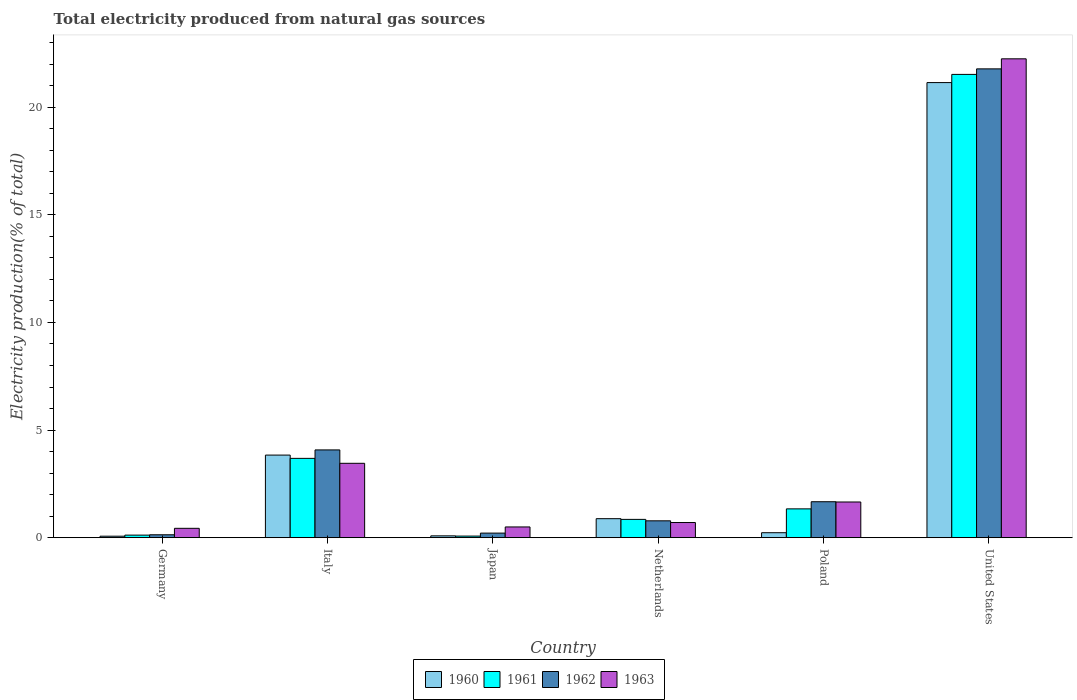How many groups of bars are there?
Provide a succinct answer. 6. Are the number of bars per tick equal to the number of legend labels?
Ensure brevity in your answer.  Yes. Are the number of bars on each tick of the X-axis equal?
Your answer should be compact. Yes. How many bars are there on the 5th tick from the right?
Your response must be concise. 4. What is the label of the 5th group of bars from the left?
Offer a terse response. Poland. In how many cases, is the number of bars for a given country not equal to the number of legend labels?
Provide a succinct answer. 0. What is the total electricity produced in 1960 in United States?
Offer a very short reply. 21.14. Across all countries, what is the maximum total electricity produced in 1962?
Give a very brief answer. 21.78. Across all countries, what is the minimum total electricity produced in 1960?
Offer a terse response. 0.07. In which country was the total electricity produced in 1963 minimum?
Your response must be concise. Germany. What is the total total electricity produced in 1961 in the graph?
Make the answer very short. 27.59. What is the difference between the total electricity produced in 1963 in Italy and that in Poland?
Offer a terse response. 1.8. What is the difference between the total electricity produced in 1961 in Poland and the total electricity produced in 1963 in Netherlands?
Your answer should be very brief. 0.63. What is the average total electricity produced in 1962 per country?
Ensure brevity in your answer.  4.78. What is the difference between the total electricity produced of/in 1960 and total electricity produced of/in 1961 in United States?
Your answer should be compact. -0.38. In how many countries, is the total electricity produced in 1962 greater than 7 %?
Offer a terse response. 1. What is the ratio of the total electricity produced in 1962 in Germany to that in Japan?
Keep it short and to the point. 0.64. What is the difference between the highest and the second highest total electricity produced in 1961?
Your answer should be compact. -2.35. What is the difference between the highest and the lowest total electricity produced in 1961?
Your response must be concise. 21.45. What does the 1st bar from the left in Italy represents?
Give a very brief answer. 1960. What does the 3rd bar from the right in Japan represents?
Your answer should be very brief. 1961. How many bars are there?
Make the answer very short. 24. Are all the bars in the graph horizontal?
Offer a terse response. No. How many countries are there in the graph?
Provide a succinct answer. 6. Are the values on the major ticks of Y-axis written in scientific E-notation?
Your answer should be compact. No. Does the graph contain any zero values?
Make the answer very short. No. Does the graph contain grids?
Your answer should be compact. No. How many legend labels are there?
Give a very brief answer. 4. What is the title of the graph?
Make the answer very short. Total electricity produced from natural gas sources. What is the label or title of the X-axis?
Your response must be concise. Country. What is the Electricity production(% of total) of 1960 in Germany?
Provide a succinct answer. 0.07. What is the Electricity production(% of total) of 1961 in Germany?
Provide a succinct answer. 0.12. What is the Electricity production(% of total) in 1962 in Germany?
Keep it short and to the point. 0.14. What is the Electricity production(% of total) of 1963 in Germany?
Your answer should be compact. 0.44. What is the Electricity production(% of total) of 1960 in Italy?
Provide a succinct answer. 3.84. What is the Electricity production(% of total) of 1961 in Italy?
Your answer should be compact. 3.69. What is the Electricity production(% of total) of 1962 in Italy?
Provide a short and direct response. 4.08. What is the Electricity production(% of total) in 1963 in Italy?
Ensure brevity in your answer.  3.46. What is the Electricity production(% of total) of 1960 in Japan?
Offer a very short reply. 0.09. What is the Electricity production(% of total) of 1961 in Japan?
Your response must be concise. 0.08. What is the Electricity production(% of total) of 1962 in Japan?
Ensure brevity in your answer.  0.21. What is the Electricity production(% of total) in 1963 in Japan?
Your response must be concise. 0.5. What is the Electricity production(% of total) of 1960 in Netherlands?
Make the answer very short. 0.88. What is the Electricity production(% of total) of 1961 in Netherlands?
Your response must be concise. 0.85. What is the Electricity production(% of total) of 1962 in Netherlands?
Your answer should be very brief. 0.78. What is the Electricity production(% of total) of 1963 in Netherlands?
Keep it short and to the point. 0.71. What is the Electricity production(% of total) of 1960 in Poland?
Make the answer very short. 0.23. What is the Electricity production(% of total) in 1961 in Poland?
Give a very brief answer. 1.34. What is the Electricity production(% of total) of 1962 in Poland?
Your answer should be very brief. 1.67. What is the Electricity production(% of total) of 1963 in Poland?
Provide a succinct answer. 1.66. What is the Electricity production(% of total) in 1960 in United States?
Your answer should be compact. 21.14. What is the Electricity production(% of total) in 1961 in United States?
Make the answer very short. 21.52. What is the Electricity production(% of total) in 1962 in United States?
Make the answer very short. 21.78. What is the Electricity production(% of total) in 1963 in United States?
Your answer should be very brief. 22.24. Across all countries, what is the maximum Electricity production(% of total) of 1960?
Make the answer very short. 21.14. Across all countries, what is the maximum Electricity production(% of total) of 1961?
Make the answer very short. 21.52. Across all countries, what is the maximum Electricity production(% of total) in 1962?
Your answer should be very brief. 21.78. Across all countries, what is the maximum Electricity production(% of total) in 1963?
Your response must be concise. 22.24. Across all countries, what is the minimum Electricity production(% of total) in 1960?
Your answer should be compact. 0.07. Across all countries, what is the minimum Electricity production(% of total) in 1961?
Provide a short and direct response. 0.08. Across all countries, what is the minimum Electricity production(% of total) of 1962?
Your answer should be compact. 0.14. Across all countries, what is the minimum Electricity production(% of total) in 1963?
Your response must be concise. 0.44. What is the total Electricity production(% of total) in 1960 in the graph?
Provide a short and direct response. 26.25. What is the total Electricity production(% of total) in 1961 in the graph?
Keep it short and to the point. 27.59. What is the total Electricity production(% of total) of 1962 in the graph?
Ensure brevity in your answer.  28.66. What is the total Electricity production(% of total) in 1963 in the graph?
Provide a succinct answer. 29. What is the difference between the Electricity production(% of total) of 1960 in Germany and that in Italy?
Provide a succinct answer. -3.77. What is the difference between the Electricity production(% of total) of 1961 in Germany and that in Italy?
Give a very brief answer. -3.57. What is the difference between the Electricity production(% of total) of 1962 in Germany and that in Italy?
Provide a short and direct response. -3.94. What is the difference between the Electricity production(% of total) of 1963 in Germany and that in Italy?
Your answer should be compact. -3.02. What is the difference between the Electricity production(% of total) in 1960 in Germany and that in Japan?
Your answer should be compact. -0.02. What is the difference between the Electricity production(% of total) of 1961 in Germany and that in Japan?
Offer a terse response. 0.04. What is the difference between the Electricity production(% of total) of 1962 in Germany and that in Japan?
Provide a short and direct response. -0.08. What is the difference between the Electricity production(% of total) in 1963 in Germany and that in Japan?
Your answer should be compact. -0.06. What is the difference between the Electricity production(% of total) of 1960 in Germany and that in Netherlands?
Provide a short and direct response. -0.81. What is the difference between the Electricity production(% of total) in 1961 in Germany and that in Netherlands?
Offer a terse response. -0.73. What is the difference between the Electricity production(% of total) in 1962 in Germany and that in Netherlands?
Keep it short and to the point. -0.65. What is the difference between the Electricity production(% of total) in 1963 in Germany and that in Netherlands?
Offer a very short reply. -0.27. What is the difference between the Electricity production(% of total) in 1960 in Germany and that in Poland?
Give a very brief answer. -0.16. What is the difference between the Electricity production(% of total) of 1961 in Germany and that in Poland?
Your answer should be very brief. -1.22. What is the difference between the Electricity production(% of total) in 1962 in Germany and that in Poland?
Give a very brief answer. -1.53. What is the difference between the Electricity production(% of total) of 1963 in Germany and that in Poland?
Your response must be concise. -1.22. What is the difference between the Electricity production(% of total) of 1960 in Germany and that in United States?
Ensure brevity in your answer.  -21.07. What is the difference between the Electricity production(% of total) of 1961 in Germany and that in United States?
Your response must be concise. -21.4. What is the difference between the Electricity production(% of total) of 1962 in Germany and that in United States?
Your answer should be compact. -21.64. What is the difference between the Electricity production(% of total) in 1963 in Germany and that in United States?
Provide a succinct answer. -21.81. What is the difference between the Electricity production(% of total) in 1960 in Italy and that in Japan?
Your answer should be very brief. 3.75. What is the difference between the Electricity production(% of total) of 1961 in Italy and that in Japan?
Make the answer very short. 3.61. What is the difference between the Electricity production(% of total) in 1962 in Italy and that in Japan?
Your answer should be very brief. 3.86. What is the difference between the Electricity production(% of total) in 1963 in Italy and that in Japan?
Your answer should be very brief. 2.96. What is the difference between the Electricity production(% of total) in 1960 in Italy and that in Netherlands?
Provide a succinct answer. 2.95. What is the difference between the Electricity production(% of total) of 1961 in Italy and that in Netherlands?
Keep it short and to the point. 2.83. What is the difference between the Electricity production(% of total) of 1962 in Italy and that in Netherlands?
Ensure brevity in your answer.  3.29. What is the difference between the Electricity production(% of total) of 1963 in Italy and that in Netherlands?
Provide a short and direct response. 2.75. What is the difference between the Electricity production(% of total) in 1960 in Italy and that in Poland?
Keep it short and to the point. 3.61. What is the difference between the Electricity production(% of total) of 1961 in Italy and that in Poland?
Your answer should be very brief. 2.35. What is the difference between the Electricity production(% of total) of 1962 in Italy and that in Poland?
Your answer should be very brief. 2.41. What is the difference between the Electricity production(% of total) in 1963 in Italy and that in Poland?
Offer a very short reply. 1.8. What is the difference between the Electricity production(% of total) in 1960 in Italy and that in United States?
Your response must be concise. -17.3. What is the difference between the Electricity production(% of total) in 1961 in Italy and that in United States?
Offer a terse response. -17.84. What is the difference between the Electricity production(% of total) in 1962 in Italy and that in United States?
Offer a terse response. -17.7. What is the difference between the Electricity production(% of total) of 1963 in Italy and that in United States?
Make the answer very short. -18.79. What is the difference between the Electricity production(% of total) in 1960 in Japan and that in Netherlands?
Provide a succinct answer. -0.8. What is the difference between the Electricity production(% of total) in 1961 in Japan and that in Netherlands?
Provide a short and direct response. -0.78. What is the difference between the Electricity production(% of total) of 1962 in Japan and that in Netherlands?
Make the answer very short. -0.57. What is the difference between the Electricity production(% of total) in 1963 in Japan and that in Netherlands?
Keep it short and to the point. -0.21. What is the difference between the Electricity production(% of total) in 1960 in Japan and that in Poland?
Your response must be concise. -0.15. What is the difference between the Electricity production(% of total) of 1961 in Japan and that in Poland?
Keep it short and to the point. -1.26. What is the difference between the Electricity production(% of total) of 1962 in Japan and that in Poland?
Offer a very short reply. -1.46. What is the difference between the Electricity production(% of total) in 1963 in Japan and that in Poland?
Your response must be concise. -1.16. What is the difference between the Electricity production(% of total) of 1960 in Japan and that in United States?
Provide a succinct answer. -21.05. What is the difference between the Electricity production(% of total) in 1961 in Japan and that in United States?
Your answer should be very brief. -21.45. What is the difference between the Electricity production(% of total) in 1962 in Japan and that in United States?
Offer a very short reply. -21.56. What is the difference between the Electricity production(% of total) in 1963 in Japan and that in United States?
Your answer should be compact. -21.74. What is the difference between the Electricity production(% of total) of 1960 in Netherlands and that in Poland?
Your answer should be compact. 0.65. What is the difference between the Electricity production(% of total) in 1961 in Netherlands and that in Poland?
Provide a short and direct response. -0.49. What is the difference between the Electricity production(% of total) in 1962 in Netherlands and that in Poland?
Provide a succinct answer. -0.89. What is the difference between the Electricity production(% of total) in 1963 in Netherlands and that in Poland?
Your answer should be compact. -0.95. What is the difference between the Electricity production(% of total) in 1960 in Netherlands and that in United States?
Provide a short and direct response. -20.26. What is the difference between the Electricity production(% of total) of 1961 in Netherlands and that in United States?
Ensure brevity in your answer.  -20.67. What is the difference between the Electricity production(% of total) in 1962 in Netherlands and that in United States?
Make the answer very short. -20.99. What is the difference between the Electricity production(% of total) of 1963 in Netherlands and that in United States?
Give a very brief answer. -21.54. What is the difference between the Electricity production(% of total) of 1960 in Poland and that in United States?
Your response must be concise. -20.91. What is the difference between the Electricity production(% of total) of 1961 in Poland and that in United States?
Offer a very short reply. -20.18. What is the difference between the Electricity production(% of total) in 1962 in Poland and that in United States?
Make the answer very short. -20.11. What is the difference between the Electricity production(% of total) of 1963 in Poland and that in United States?
Your answer should be very brief. -20.59. What is the difference between the Electricity production(% of total) of 1960 in Germany and the Electricity production(% of total) of 1961 in Italy?
Your answer should be very brief. -3.62. What is the difference between the Electricity production(% of total) of 1960 in Germany and the Electricity production(% of total) of 1962 in Italy?
Your response must be concise. -4.01. What is the difference between the Electricity production(% of total) of 1960 in Germany and the Electricity production(% of total) of 1963 in Italy?
Provide a succinct answer. -3.39. What is the difference between the Electricity production(% of total) in 1961 in Germany and the Electricity production(% of total) in 1962 in Italy?
Your answer should be compact. -3.96. What is the difference between the Electricity production(% of total) in 1961 in Germany and the Electricity production(% of total) in 1963 in Italy?
Your answer should be very brief. -3.34. What is the difference between the Electricity production(% of total) of 1962 in Germany and the Electricity production(% of total) of 1963 in Italy?
Your answer should be very brief. -3.32. What is the difference between the Electricity production(% of total) of 1960 in Germany and the Electricity production(% of total) of 1961 in Japan?
Provide a short and direct response. -0.01. What is the difference between the Electricity production(% of total) of 1960 in Germany and the Electricity production(% of total) of 1962 in Japan?
Your answer should be very brief. -0.14. What is the difference between the Electricity production(% of total) of 1960 in Germany and the Electricity production(% of total) of 1963 in Japan?
Keep it short and to the point. -0.43. What is the difference between the Electricity production(% of total) of 1961 in Germany and the Electricity production(% of total) of 1962 in Japan?
Ensure brevity in your answer.  -0.09. What is the difference between the Electricity production(% of total) of 1961 in Germany and the Electricity production(% of total) of 1963 in Japan?
Give a very brief answer. -0.38. What is the difference between the Electricity production(% of total) of 1962 in Germany and the Electricity production(% of total) of 1963 in Japan?
Keep it short and to the point. -0.36. What is the difference between the Electricity production(% of total) in 1960 in Germany and the Electricity production(% of total) in 1961 in Netherlands?
Your answer should be compact. -0.78. What is the difference between the Electricity production(% of total) in 1960 in Germany and the Electricity production(% of total) in 1962 in Netherlands?
Offer a very short reply. -0.71. What is the difference between the Electricity production(% of total) of 1960 in Germany and the Electricity production(% of total) of 1963 in Netherlands?
Your answer should be compact. -0.64. What is the difference between the Electricity production(% of total) of 1961 in Germany and the Electricity production(% of total) of 1962 in Netherlands?
Give a very brief answer. -0.66. What is the difference between the Electricity production(% of total) in 1961 in Germany and the Electricity production(% of total) in 1963 in Netherlands?
Offer a very short reply. -0.58. What is the difference between the Electricity production(% of total) in 1962 in Germany and the Electricity production(% of total) in 1963 in Netherlands?
Your answer should be very brief. -0.57. What is the difference between the Electricity production(% of total) in 1960 in Germany and the Electricity production(% of total) in 1961 in Poland?
Give a very brief answer. -1.27. What is the difference between the Electricity production(% of total) of 1960 in Germany and the Electricity production(% of total) of 1962 in Poland?
Provide a short and direct response. -1.6. What is the difference between the Electricity production(% of total) in 1960 in Germany and the Electricity production(% of total) in 1963 in Poland?
Offer a terse response. -1.59. What is the difference between the Electricity production(% of total) of 1961 in Germany and the Electricity production(% of total) of 1962 in Poland?
Your response must be concise. -1.55. What is the difference between the Electricity production(% of total) of 1961 in Germany and the Electricity production(% of total) of 1963 in Poland?
Your answer should be compact. -1.54. What is the difference between the Electricity production(% of total) of 1962 in Germany and the Electricity production(% of total) of 1963 in Poland?
Keep it short and to the point. -1.52. What is the difference between the Electricity production(% of total) of 1960 in Germany and the Electricity production(% of total) of 1961 in United States?
Offer a terse response. -21.45. What is the difference between the Electricity production(% of total) in 1960 in Germany and the Electricity production(% of total) in 1962 in United States?
Keep it short and to the point. -21.71. What is the difference between the Electricity production(% of total) of 1960 in Germany and the Electricity production(% of total) of 1963 in United States?
Your answer should be very brief. -22.17. What is the difference between the Electricity production(% of total) in 1961 in Germany and the Electricity production(% of total) in 1962 in United States?
Give a very brief answer. -21.66. What is the difference between the Electricity production(% of total) in 1961 in Germany and the Electricity production(% of total) in 1963 in United States?
Provide a short and direct response. -22.12. What is the difference between the Electricity production(% of total) in 1962 in Germany and the Electricity production(% of total) in 1963 in United States?
Ensure brevity in your answer.  -22.11. What is the difference between the Electricity production(% of total) in 1960 in Italy and the Electricity production(% of total) in 1961 in Japan?
Offer a terse response. 3.76. What is the difference between the Electricity production(% of total) of 1960 in Italy and the Electricity production(% of total) of 1962 in Japan?
Your answer should be very brief. 3.62. What is the difference between the Electricity production(% of total) of 1960 in Italy and the Electricity production(% of total) of 1963 in Japan?
Offer a terse response. 3.34. What is the difference between the Electricity production(% of total) of 1961 in Italy and the Electricity production(% of total) of 1962 in Japan?
Provide a short and direct response. 3.47. What is the difference between the Electricity production(% of total) of 1961 in Italy and the Electricity production(% of total) of 1963 in Japan?
Make the answer very short. 3.19. What is the difference between the Electricity production(% of total) of 1962 in Italy and the Electricity production(% of total) of 1963 in Japan?
Offer a very short reply. 3.58. What is the difference between the Electricity production(% of total) in 1960 in Italy and the Electricity production(% of total) in 1961 in Netherlands?
Provide a succinct answer. 2.99. What is the difference between the Electricity production(% of total) in 1960 in Italy and the Electricity production(% of total) in 1962 in Netherlands?
Make the answer very short. 3.05. What is the difference between the Electricity production(% of total) in 1960 in Italy and the Electricity production(% of total) in 1963 in Netherlands?
Provide a short and direct response. 3.13. What is the difference between the Electricity production(% of total) of 1961 in Italy and the Electricity production(% of total) of 1962 in Netherlands?
Give a very brief answer. 2.9. What is the difference between the Electricity production(% of total) of 1961 in Italy and the Electricity production(% of total) of 1963 in Netherlands?
Keep it short and to the point. 2.98. What is the difference between the Electricity production(% of total) of 1962 in Italy and the Electricity production(% of total) of 1963 in Netherlands?
Your response must be concise. 3.37. What is the difference between the Electricity production(% of total) in 1960 in Italy and the Electricity production(% of total) in 1961 in Poland?
Make the answer very short. 2.5. What is the difference between the Electricity production(% of total) of 1960 in Italy and the Electricity production(% of total) of 1962 in Poland?
Your answer should be very brief. 2.17. What is the difference between the Electricity production(% of total) of 1960 in Italy and the Electricity production(% of total) of 1963 in Poland?
Keep it short and to the point. 2.18. What is the difference between the Electricity production(% of total) in 1961 in Italy and the Electricity production(% of total) in 1962 in Poland?
Your answer should be very brief. 2.01. What is the difference between the Electricity production(% of total) in 1961 in Italy and the Electricity production(% of total) in 1963 in Poland?
Keep it short and to the point. 2.03. What is the difference between the Electricity production(% of total) in 1962 in Italy and the Electricity production(% of total) in 1963 in Poland?
Ensure brevity in your answer.  2.42. What is the difference between the Electricity production(% of total) of 1960 in Italy and the Electricity production(% of total) of 1961 in United States?
Provide a short and direct response. -17.68. What is the difference between the Electricity production(% of total) in 1960 in Italy and the Electricity production(% of total) in 1962 in United States?
Provide a succinct answer. -17.94. What is the difference between the Electricity production(% of total) in 1960 in Italy and the Electricity production(% of total) in 1963 in United States?
Offer a very short reply. -18.41. What is the difference between the Electricity production(% of total) of 1961 in Italy and the Electricity production(% of total) of 1962 in United States?
Your answer should be compact. -18.09. What is the difference between the Electricity production(% of total) in 1961 in Italy and the Electricity production(% of total) in 1963 in United States?
Offer a very short reply. -18.56. What is the difference between the Electricity production(% of total) of 1962 in Italy and the Electricity production(% of total) of 1963 in United States?
Keep it short and to the point. -18.17. What is the difference between the Electricity production(% of total) in 1960 in Japan and the Electricity production(% of total) in 1961 in Netherlands?
Provide a short and direct response. -0.76. What is the difference between the Electricity production(% of total) of 1960 in Japan and the Electricity production(% of total) of 1962 in Netherlands?
Your response must be concise. -0.7. What is the difference between the Electricity production(% of total) in 1960 in Japan and the Electricity production(% of total) in 1963 in Netherlands?
Give a very brief answer. -0.62. What is the difference between the Electricity production(% of total) in 1961 in Japan and the Electricity production(% of total) in 1962 in Netherlands?
Your answer should be compact. -0.71. What is the difference between the Electricity production(% of total) of 1961 in Japan and the Electricity production(% of total) of 1963 in Netherlands?
Your response must be concise. -0.63. What is the difference between the Electricity production(% of total) of 1962 in Japan and the Electricity production(% of total) of 1963 in Netherlands?
Offer a terse response. -0.49. What is the difference between the Electricity production(% of total) of 1960 in Japan and the Electricity production(% of total) of 1961 in Poland?
Keep it short and to the point. -1.25. What is the difference between the Electricity production(% of total) of 1960 in Japan and the Electricity production(% of total) of 1962 in Poland?
Give a very brief answer. -1.58. What is the difference between the Electricity production(% of total) in 1960 in Japan and the Electricity production(% of total) in 1963 in Poland?
Keep it short and to the point. -1.57. What is the difference between the Electricity production(% of total) of 1961 in Japan and the Electricity production(% of total) of 1962 in Poland?
Make the answer very short. -1.6. What is the difference between the Electricity production(% of total) of 1961 in Japan and the Electricity production(% of total) of 1963 in Poland?
Provide a succinct answer. -1.58. What is the difference between the Electricity production(% of total) in 1962 in Japan and the Electricity production(% of total) in 1963 in Poland?
Your answer should be compact. -1.45. What is the difference between the Electricity production(% of total) in 1960 in Japan and the Electricity production(% of total) in 1961 in United States?
Your response must be concise. -21.43. What is the difference between the Electricity production(% of total) in 1960 in Japan and the Electricity production(% of total) in 1962 in United States?
Ensure brevity in your answer.  -21.69. What is the difference between the Electricity production(% of total) in 1960 in Japan and the Electricity production(% of total) in 1963 in United States?
Provide a succinct answer. -22.16. What is the difference between the Electricity production(% of total) of 1961 in Japan and the Electricity production(% of total) of 1962 in United States?
Your answer should be compact. -21.7. What is the difference between the Electricity production(% of total) in 1961 in Japan and the Electricity production(% of total) in 1963 in United States?
Your answer should be very brief. -22.17. What is the difference between the Electricity production(% of total) of 1962 in Japan and the Electricity production(% of total) of 1963 in United States?
Your answer should be very brief. -22.03. What is the difference between the Electricity production(% of total) of 1960 in Netherlands and the Electricity production(% of total) of 1961 in Poland?
Your response must be concise. -0.46. What is the difference between the Electricity production(% of total) in 1960 in Netherlands and the Electricity production(% of total) in 1962 in Poland?
Your response must be concise. -0.79. What is the difference between the Electricity production(% of total) in 1960 in Netherlands and the Electricity production(% of total) in 1963 in Poland?
Your answer should be very brief. -0.78. What is the difference between the Electricity production(% of total) of 1961 in Netherlands and the Electricity production(% of total) of 1962 in Poland?
Provide a short and direct response. -0.82. What is the difference between the Electricity production(% of total) in 1961 in Netherlands and the Electricity production(% of total) in 1963 in Poland?
Your answer should be very brief. -0.81. What is the difference between the Electricity production(% of total) in 1962 in Netherlands and the Electricity production(% of total) in 1963 in Poland?
Provide a succinct answer. -0.88. What is the difference between the Electricity production(% of total) of 1960 in Netherlands and the Electricity production(% of total) of 1961 in United States?
Offer a terse response. -20.64. What is the difference between the Electricity production(% of total) of 1960 in Netherlands and the Electricity production(% of total) of 1962 in United States?
Your response must be concise. -20.89. What is the difference between the Electricity production(% of total) of 1960 in Netherlands and the Electricity production(% of total) of 1963 in United States?
Make the answer very short. -21.36. What is the difference between the Electricity production(% of total) in 1961 in Netherlands and the Electricity production(% of total) in 1962 in United States?
Ensure brevity in your answer.  -20.93. What is the difference between the Electricity production(% of total) of 1961 in Netherlands and the Electricity production(% of total) of 1963 in United States?
Give a very brief answer. -21.39. What is the difference between the Electricity production(% of total) of 1962 in Netherlands and the Electricity production(% of total) of 1963 in United States?
Your answer should be very brief. -21.46. What is the difference between the Electricity production(% of total) of 1960 in Poland and the Electricity production(% of total) of 1961 in United States?
Make the answer very short. -21.29. What is the difference between the Electricity production(% of total) of 1960 in Poland and the Electricity production(% of total) of 1962 in United States?
Give a very brief answer. -21.55. What is the difference between the Electricity production(% of total) of 1960 in Poland and the Electricity production(% of total) of 1963 in United States?
Your answer should be very brief. -22.01. What is the difference between the Electricity production(% of total) of 1961 in Poland and the Electricity production(% of total) of 1962 in United States?
Offer a very short reply. -20.44. What is the difference between the Electricity production(% of total) in 1961 in Poland and the Electricity production(% of total) in 1963 in United States?
Offer a terse response. -20.91. What is the difference between the Electricity production(% of total) of 1962 in Poland and the Electricity production(% of total) of 1963 in United States?
Provide a short and direct response. -20.57. What is the average Electricity production(% of total) of 1960 per country?
Provide a short and direct response. 4.38. What is the average Electricity production(% of total) of 1961 per country?
Offer a terse response. 4.6. What is the average Electricity production(% of total) in 1962 per country?
Your answer should be compact. 4.78. What is the average Electricity production(% of total) of 1963 per country?
Make the answer very short. 4.83. What is the difference between the Electricity production(% of total) of 1960 and Electricity production(% of total) of 1961 in Germany?
Offer a terse response. -0.05. What is the difference between the Electricity production(% of total) in 1960 and Electricity production(% of total) in 1962 in Germany?
Provide a short and direct response. -0.07. What is the difference between the Electricity production(% of total) in 1960 and Electricity production(% of total) in 1963 in Germany?
Make the answer very short. -0.37. What is the difference between the Electricity production(% of total) in 1961 and Electricity production(% of total) in 1962 in Germany?
Make the answer very short. -0.02. What is the difference between the Electricity production(% of total) of 1961 and Electricity production(% of total) of 1963 in Germany?
Offer a terse response. -0.32. What is the difference between the Electricity production(% of total) of 1962 and Electricity production(% of total) of 1963 in Germany?
Ensure brevity in your answer.  -0.3. What is the difference between the Electricity production(% of total) of 1960 and Electricity production(% of total) of 1961 in Italy?
Provide a short and direct response. 0.15. What is the difference between the Electricity production(% of total) in 1960 and Electricity production(% of total) in 1962 in Italy?
Your response must be concise. -0.24. What is the difference between the Electricity production(% of total) in 1960 and Electricity production(% of total) in 1963 in Italy?
Offer a terse response. 0.38. What is the difference between the Electricity production(% of total) of 1961 and Electricity production(% of total) of 1962 in Italy?
Offer a terse response. -0.39. What is the difference between the Electricity production(% of total) of 1961 and Electricity production(% of total) of 1963 in Italy?
Make the answer very short. 0.23. What is the difference between the Electricity production(% of total) of 1962 and Electricity production(% of total) of 1963 in Italy?
Ensure brevity in your answer.  0.62. What is the difference between the Electricity production(% of total) of 1960 and Electricity production(% of total) of 1961 in Japan?
Provide a short and direct response. 0.01. What is the difference between the Electricity production(% of total) of 1960 and Electricity production(% of total) of 1962 in Japan?
Make the answer very short. -0.13. What is the difference between the Electricity production(% of total) in 1960 and Electricity production(% of total) in 1963 in Japan?
Offer a terse response. -0.41. What is the difference between the Electricity production(% of total) in 1961 and Electricity production(% of total) in 1962 in Japan?
Ensure brevity in your answer.  -0.14. What is the difference between the Electricity production(% of total) in 1961 and Electricity production(% of total) in 1963 in Japan?
Provide a short and direct response. -0.42. What is the difference between the Electricity production(% of total) of 1962 and Electricity production(% of total) of 1963 in Japan?
Your answer should be very brief. -0.29. What is the difference between the Electricity production(% of total) in 1960 and Electricity production(% of total) in 1961 in Netherlands?
Provide a succinct answer. 0.03. What is the difference between the Electricity production(% of total) in 1960 and Electricity production(% of total) in 1962 in Netherlands?
Give a very brief answer. 0.1. What is the difference between the Electricity production(% of total) of 1960 and Electricity production(% of total) of 1963 in Netherlands?
Ensure brevity in your answer.  0.18. What is the difference between the Electricity production(% of total) of 1961 and Electricity production(% of total) of 1962 in Netherlands?
Provide a short and direct response. 0.07. What is the difference between the Electricity production(% of total) of 1961 and Electricity production(% of total) of 1963 in Netherlands?
Your response must be concise. 0.15. What is the difference between the Electricity production(% of total) in 1962 and Electricity production(% of total) in 1963 in Netherlands?
Keep it short and to the point. 0.08. What is the difference between the Electricity production(% of total) of 1960 and Electricity production(% of total) of 1961 in Poland?
Your response must be concise. -1.11. What is the difference between the Electricity production(% of total) in 1960 and Electricity production(% of total) in 1962 in Poland?
Offer a very short reply. -1.44. What is the difference between the Electricity production(% of total) in 1960 and Electricity production(% of total) in 1963 in Poland?
Make the answer very short. -1.43. What is the difference between the Electricity production(% of total) of 1961 and Electricity production(% of total) of 1962 in Poland?
Provide a short and direct response. -0.33. What is the difference between the Electricity production(% of total) of 1961 and Electricity production(% of total) of 1963 in Poland?
Ensure brevity in your answer.  -0.32. What is the difference between the Electricity production(% of total) of 1962 and Electricity production(% of total) of 1963 in Poland?
Make the answer very short. 0.01. What is the difference between the Electricity production(% of total) of 1960 and Electricity production(% of total) of 1961 in United States?
Make the answer very short. -0.38. What is the difference between the Electricity production(% of total) in 1960 and Electricity production(% of total) in 1962 in United States?
Ensure brevity in your answer.  -0.64. What is the difference between the Electricity production(% of total) in 1960 and Electricity production(% of total) in 1963 in United States?
Your answer should be compact. -1.1. What is the difference between the Electricity production(% of total) in 1961 and Electricity production(% of total) in 1962 in United States?
Give a very brief answer. -0.26. What is the difference between the Electricity production(% of total) of 1961 and Electricity production(% of total) of 1963 in United States?
Offer a very short reply. -0.72. What is the difference between the Electricity production(% of total) of 1962 and Electricity production(% of total) of 1963 in United States?
Keep it short and to the point. -0.47. What is the ratio of the Electricity production(% of total) of 1960 in Germany to that in Italy?
Provide a succinct answer. 0.02. What is the ratio of the Electricity production(% of total) of 1961 in Germany to that in Italy?
Your response must be concise. 0.03. What is the ratio of the Electricity production(% of total) in 1962 in Germany to that in Italy?
Your response must be concise. 0.03. What is the ratio of the Electricity production(% of total) in 1963 in Germany to that in Italy?
Offer a very short reply. 0.13. What is the ratio of the Electricity production(% of total) in 1960 in Germany to that in Japan?
Provide a succinct answer. 0.81. What is the ratio of the Electricity production(% of total) in 1961 in Germany to that in Japan?
Give a very brief answer. 1.59. What is the ratio of the Electricity production(% of total) of 1962 in Germany to that in Japan?
Your response must be concise. 0.64. What is the ratio of the Electricity production(% of total) of 1963 in Germany to that in Japan?
Offer a terse response. 0.87. What is the ratio of the Electricity production(% of total) in 1960 in Germany to that in Netherlands?
Make the answer very short. 0.08. What is the ratio of the Electricity production(% of total) in 1961 in Germany to that in Netherlands?
Offer a very short reply. 0.14. What is the ratio of the Electricity production(% of total) of 1962 in Germany to that in Netherlands?
Provide a succinct answer. 0.17. What is the ratio of the Electricity production(% of total) of 1963 in Germany to that in Netherlands?
Keep it short and to the point. 0.62. What is the ratio of the Electricity production(% of total) of 1960 in Germany to that in Poland?
Keep it short and to the point. 0.3. What is the ratio of the Electricity production(% of total) in 1961 in Germany to that in Poland?
Make the answer very short. 0.09. What is the ratio of the Electricity production(% of total) in 1962 in Germany to that in Poland?
Make the answer very short. 0.08. What is the ratio of the Electricity production(% of total) in 1963 in Germany to that in Poland?
Provide a succinct answer. 0.26. What is the ratio of the Electricity production(% of total) in 1960 in Germany to that in United States?
Make the answer very short. 0. What is the ratio of the Electricity production(% of total) in 1961 in Germany to that in United States?
Your response must be concise. 0.01. What is the ratio of the Electricity production(% of total) in 1962 in Germany to that in United States?
Provide a succinct answer. 0.01. What is the ratio of the Electricity production(% of total) of 1963 in Germany to that in United States?
Provide a succinct answer. 0.02. What is the ratio of the Electricity production(% of total) in 1960 in Italy to that in Japan?
Your response must be concise. 44.33. What is the ratio of the Electricity production(% of total) in 1961 in Italy to that in Japan?
Your answer should be compact. 48.69. What is the ratio of the Electricity production(% of total) in 1962 in Italy to that in Japan?
Offer a very short reply. 19.09. What is the ratio of the Electricity production(% of total) in 1963 in Italy to that in Japan?
Keep it short and to the point. 6.91. What is the ratio of the Electricity production(% of total) of 1960 in Italy to that in Netherlands?
Your answer should be compact. 4.34. What is the ratio of the Electricity production(% of total) of 1961 in Italy to that in Netherlands?
Give a very brief answer. 4.33. What is the ratio of the Electricity production(% of total) of 1962 in Italy to that in Netherlands?
Make the answer very short. 5.2. What is the ratio of the Electricity production(% of total) in 1963 in Italy to that in Netherlands?
Keep it short and to the point. 4.9. What is the ratio of the Electricity production(% of total) of 1960 in Italy to that in Poland?
Your answer should be very brief. 16.53. What is the ratio of the Electricity production(% of total) of 1961 in Italy to that in Poland?
Your answer should be very brief. 2.75. What is the ratio of the Electricity production(% of total) of 1962 in Italy to that in Poland?
Your answer should be very brief. 2.44. What is the ratio of the Electricity production(% of total) of 1963 in Italy to that in Poland?
Offer a very short reply. 2.08. What is the ratio of the Electricity production(% of total) of 1960 in Italy to that in United States?
Your answer should be compact. 0.18. What is the ratio of the Electricity production(% of total) in 1961 in Italy to that in United States?
Offer a very short reply. 0.17. What is the ratio of the Electricity production(% of total) in 1962 in Italy to that in United States?
Your answer should be compact. 0.19. What is the ratio of the Electricity production(% of total) in 1963 in Italy to that in United States?
Offer a very short reply. 0.16. What is the ratio of the Electricity production(% of total) of 1960 in Japan to that in Netherlands?
Provide a short and direct response. 0.1. What is the ratio of the Electricity production(% of total) in 1961 in Japan to that in Netherlands?
Offer a terse response. 0.09. What is the ratio of the Electricity production(% of total) in 1962 in Japan to that in Netherlands?
Your response must be concise. 0.27. What is the ratio of the Electricity production(% of total) in 1963 in Japan to that in Netherlands?
Offer a terse response. 0.71. What is the ratio of the Electricity production(% of total) in 1960 in Japan to that in Poland?
Keep it short and to the point. 0.37. What is the ratio of the Electricity production(% of total) of 1961 in Japan to that in Poland?
Your answer should be very brief. 0.06. What is the ratio of the Electricity production(% of total) of 1962 in Japan to that in Poland?
Offer a very short reply. 0.13. What is the ratio of the Electricity production(% of total) of 1963 in Japan to that in Poland?
Your answer should be very brief. 0.3. What is the ratio of the Electricity production(% of total) in 1960 in Japan to that in United States?
Make the answer very short. 0. What is the ratio of the Electricity production(% of total) in 1961 in Japan to that in United States?
Offer a very short reply. 0. What is the ratio of the Electricity production(% of total) in 1962 in Japan to that in United States?
Offer a very short reply. 0.01. What is the ratio of the Electricity production(% of total) of 1963 in Japan to that in United States?
Provide a succinct answer. 0.02. What is the ratio of the Electricity production(% of total) of 1960 in Netherlands to that in Poland?
Give a very brief answer. 3.81. What is the ratio of the Electricity production(% of total) in 1961 in Netherlands to that in Poland?
Give a very brief answer. 0.64. What is the ratio of the Electricity production(% of total) in 1962 in Netherlands to that in Poland?
Provide a short and direct response. 0.47. What is the ratio of the Electricity production(% of total) in 1963 in Netherlands to that in Poland?
Your answer should be very brief. 0.42. What is the ratio of the Electricity production(% of total) of 1960 in Netherlands to that in United States?
Your response must be concise. 0.04. What is the ratio of the Electricity production(% of total) in 1961 in Netherlands to that in United States?
Make the answer very short. 0.04. What is the ratio of the Electricity production(% of total) in 1962 in Netherlands to that in United States?
Keep it short and to the point. 0.04. What is the ratio of the Electricity production(% of total) of 1963 in Netherlands to that in United States?
Offer a very short reply. 0.03. What is the ratio of the Electricity production(% of total) in 1960 in Poland to that in United States?
Give a very brief answer. 0.01. What is the ratio of the Electricity production(% of total) in 1961 in Poland to that in United States?
Your answer should be very brief. 0.06. What is the ratio of the Electricity production(% of total) in 1962 in Poland to that in United States?
Offer a very short reply. 0.08. What is the ratio of the Electricity production(% of total) in 1963 in Poland to that in United States?
Keep it short and to the point. 0.07. What is the difference between the highest and the second highest Electricity production(% of total) in 1960?
Provide a short and direct response. 17.3. What is the difference between the highest and the second highest Electricity production(% of total) of 1961?
Give a very brief answer. 17.84. What is the difference between the highest and the second highest Electricity production(% of total) in 1962?
Offer a terse response. 17.7. What is the difference between the highest and the second highest Electricity production(% of total) in 1963?
Offer a very short reply. 18.79. What is the difference between the highest and the lowest Electricity production(% of total) of 1960?
Ensure brevity in your answer.  21.07. What is the difference between the highest and the lowest Electricity production(% of total) of 1961?
Your answer should be very brief. 21.45. What is the difference between the highest and the lowest Electricity production(% of total) in 1962?
Your answer should be compact. 21.64. What is the difference between the highest and the lowest Electricity production(% of total) in 1963?
Your answer should be compact. 21.81. 